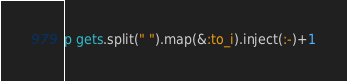Convert code to text. <code><loc_0><loc_0><loc_500><loc_500><_Ruby_>p gets.split(" ").map(&:to_i).inject(:-)+1</code> 